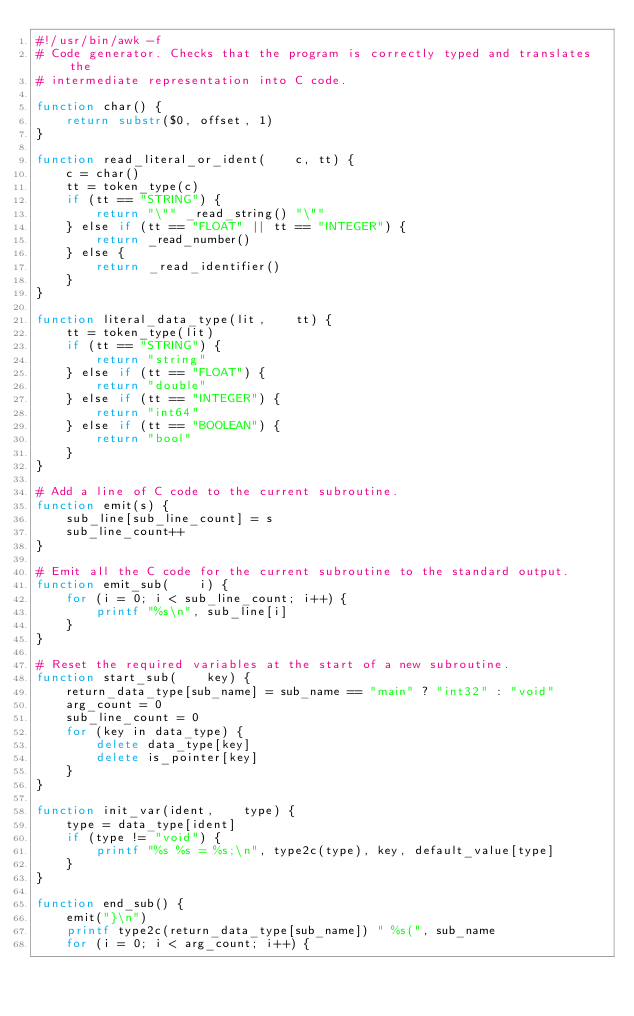<code> <loc_0><loc_0><loc_500><loc_500><_Awk_>#!/usr/bin/awk -f
# Code generator. Checks that the program is correctly typed and translates the
# intermediate representation into C code.

function char() {
    return substr($0, offset, 1)
}

function read_literal_or_ident(    c, tt) {
    c = char()
    tt = token_type(c)
    if (tt == "STRING") {
        return "\"" _read_string() "\""
    } else if (tt == "FLOAT" || tt == "INTEGER") {
        return _read_number()
    } else {
        return _read_identifier()
    }
}

function literal_data_type(lit,    tt) {
    tt = token_type(lit)
    if (tt == "STRING") {
        return "string"
    } else if (tt == "FLOAT") {
        return "double"
    } else if (tt == "INTEGER") {
        return "int64"
    } else if (tt == "BOOLEAN") {
        return "bool"
    }
}

# Add a line of C code to the current subroutine.
function emit(s) {
    sub_line[sub_line_count] = s
    sub_line_count++
}

# Emit all the C code for the current subroutine to the standard output.
function emit_sub(    i) {
    for (i = 0; i < sub_line_count; i++) {
        printf "%s\n", sub_line[i]
    }
}

# Reset the required variables at the start of a new subroutine.
function start_sub(    key) {
    return_data_type[sub_name] = sub_name == "main" ? "int32" : "void"
    arg_count = 0
    sub_line_count = 0
    for (key in data_type) {
        delete data_type[key]
        delete is_pointer[key]
    }
}

function init_var(ident,    type) {
    type = data_type[ident]
    if (type != "void") {
        printf "%s %s = %s;\n", type2c(type), key, default_value[type]
    }
}

function end_sub() {
    emit("}\n")
    printf type2c(return_data_type[sub_name]) " %s(", sub_name
    for (i = 0; i < arg_count; i++) {</code> 